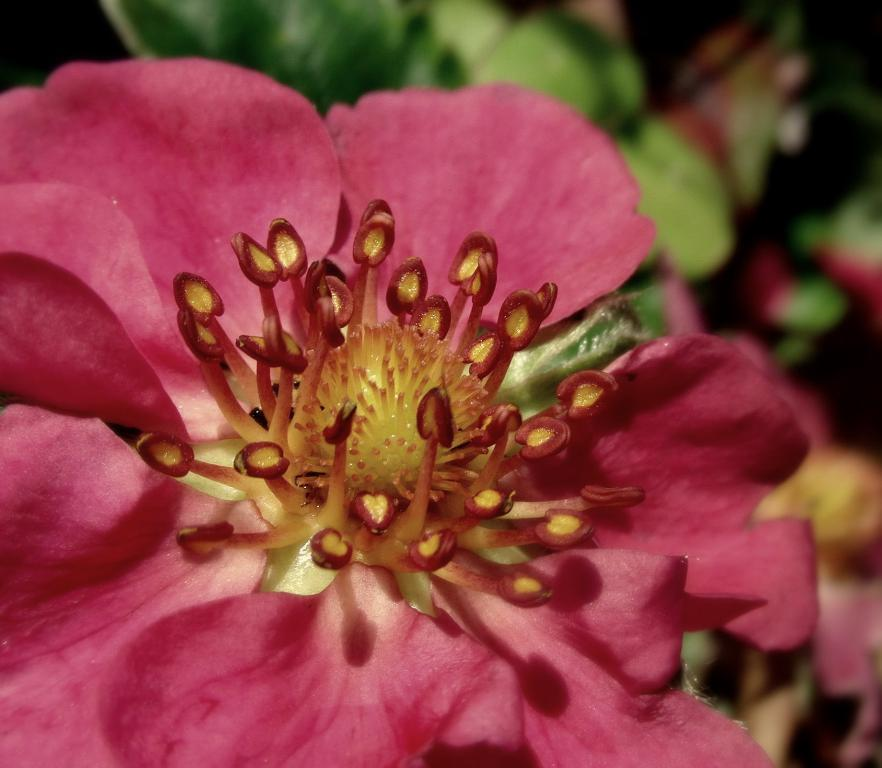What is the main subject of the image? There is a flower in the image. What can be seen in the background of the image? The background of the image includes leaves. How would you describe the quality of the image? The image is blurry. How many trails can be seen in the image? There are no trails present in the image; it features a flower and leaves in the background. What type of cherry is being used as a prop in the image? There is no cherry present in the image. 